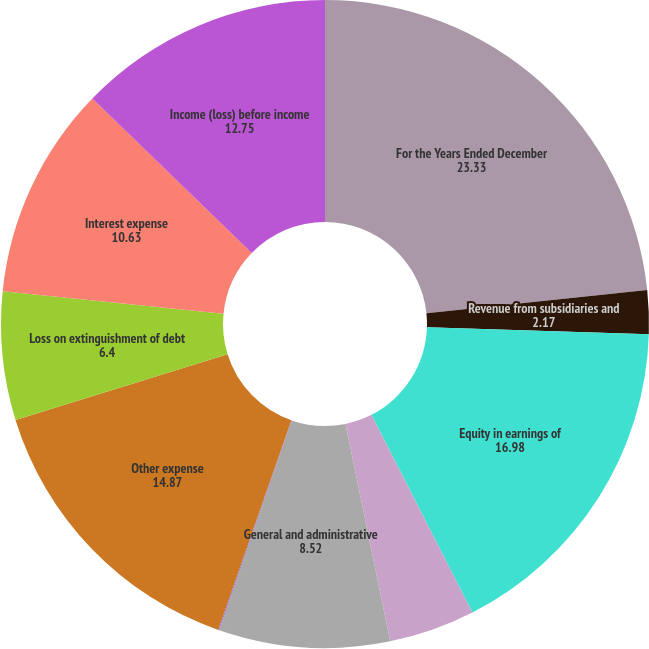Convert chart to OTSL. <chart><loc_0><loc_0><loc_500><loc_500><pie_chart><fcel>For the Years Ended December<fcel>Revenue from subsidiaries and<fcel>Equity in earnings of<fcel>Interest income<fcel>General and administrative<fcel>Other income<fcel>Other expense<fcel>Loss on extinguishment of debt<fcel>Interest expense<fcel>Income (loss) before income<nl><fcel>23.33%<fcel>2.17%<fcel>16.98%<fcel>4.29%<fcel>8.52%<fcel>0.05%<fcel>14.87%<fcel>6.4%<fcel>10.63%<fcel>12.75%<nl></chart> 